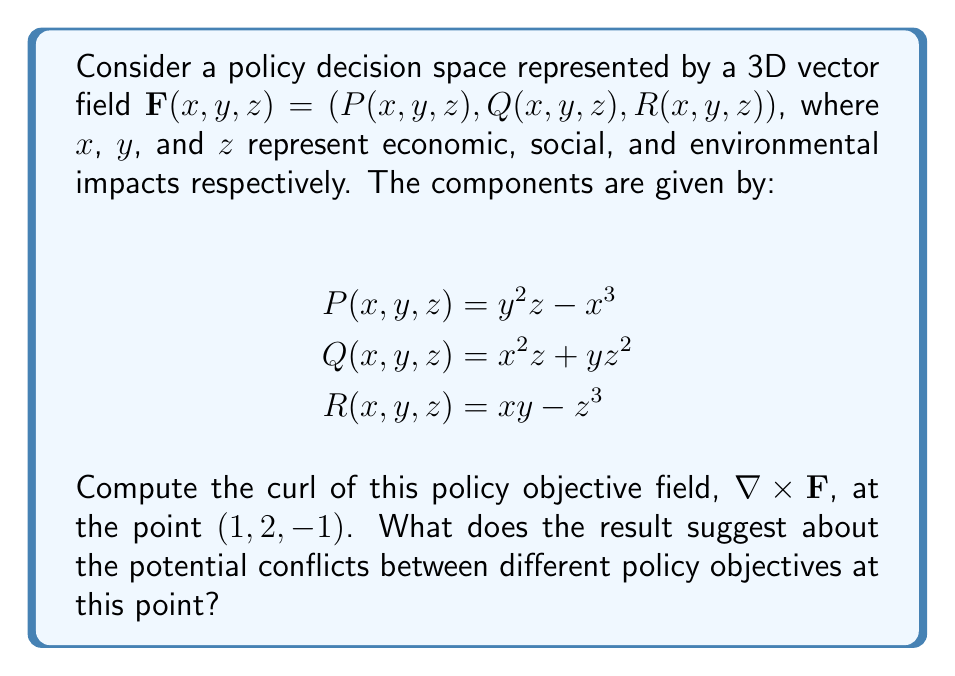Can you solve this math problem? To solve this problem, we'll follow these steps:

1) Recall the formula for curl in 3D:
   $$\nabla \times \mathbf{F} = \left(\frac{\partial R}{\partial y} - \frac{\partial Q}{\partial z}\right)\mathbf{i} + \left(\frac{\partial P}{\partial z} - \frac{\partial R}{\partial x}\right)\mathbf{j} + \left(\frac{\partial Q}{\partial x} - \frac{\partial P}{\partial y}\right)\mathbf{k}$$

2) Calculate the partial derivatives:
   $\frac{\partial R}{\partial y} = x$
   $\frac{\partial Q}{\partial z} = x^2 + 2yz$
   $\frac{\partial P}{\partial z} = y^2$
   $\frac{\partial R}{\partial x} = y$
   $\frac{\partial Q}{\partial x} = 2xz$
   $\frac{\partial P}{\partial y} = 2yz$

3) Substitute these into the curl formula:
   $$\nabla \times \mathbf{F} = (x - x^2 - 2yz)\mathbf{i} + (y^2 - y)\mathbf{j} + (2xz - 2yz)\mathbf{k}$$

4) Evaluate at the point (1, 2, -1):
   $$\nabla \times \mathbf{F}(1,2,-1) = (1 - 1^2 - 2(2)(-1))\mathbf{i} + (2^2 - 2)\mathbf{j} + (2(1)(-1) - 2(2)(-1))\mathbf{k}$$
   $$= (5)\mathbf{i} + (2)\mathbf{j} + (2)\mathbf{k}$$

5) Interpretation: The non-zero curl indicates that there are conflicting policy objectives at this point. The magnitude of the i-component (economic) is larger than the j (social) and k (environmental) components, suggesting that the greatest conflicts involve economic objectives.
Answer: $(5, 2, 2)$ 